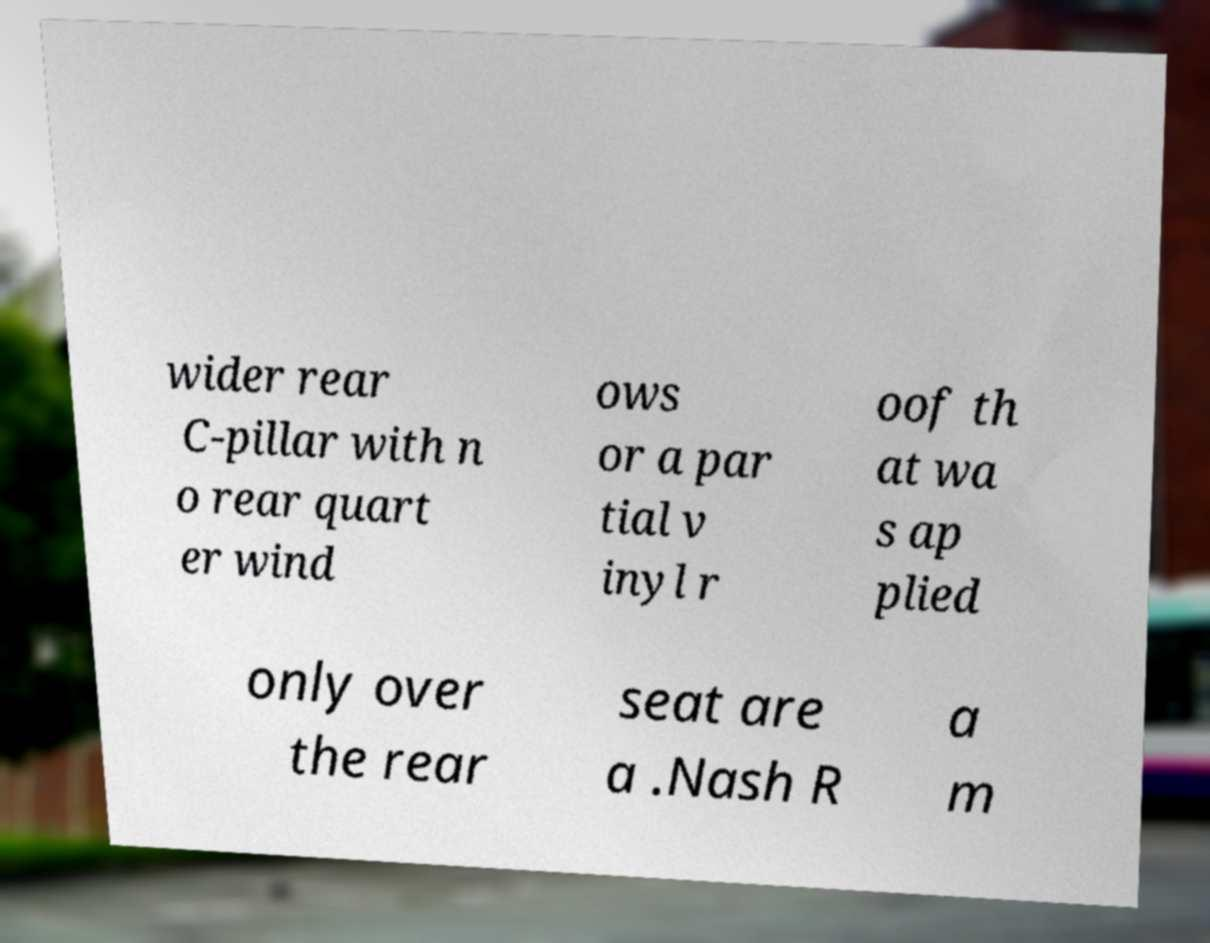Could you extract and type out the text from this image? wider rear C-pillar with n o rear quart er wind ows or a par tial v inyl r oof th at wa s ap plied only over the rear seat are a .Nash R a m 